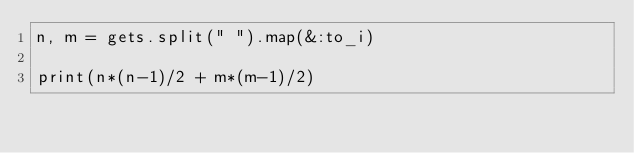Convert code to text. <code><loc_0><loc_0><loc_500><loc_500><_Ruby_>n, m = gets.split(" ").map(&:to_i)

print(n*(n-1)/2 + m*(m-1)/2)</code> 